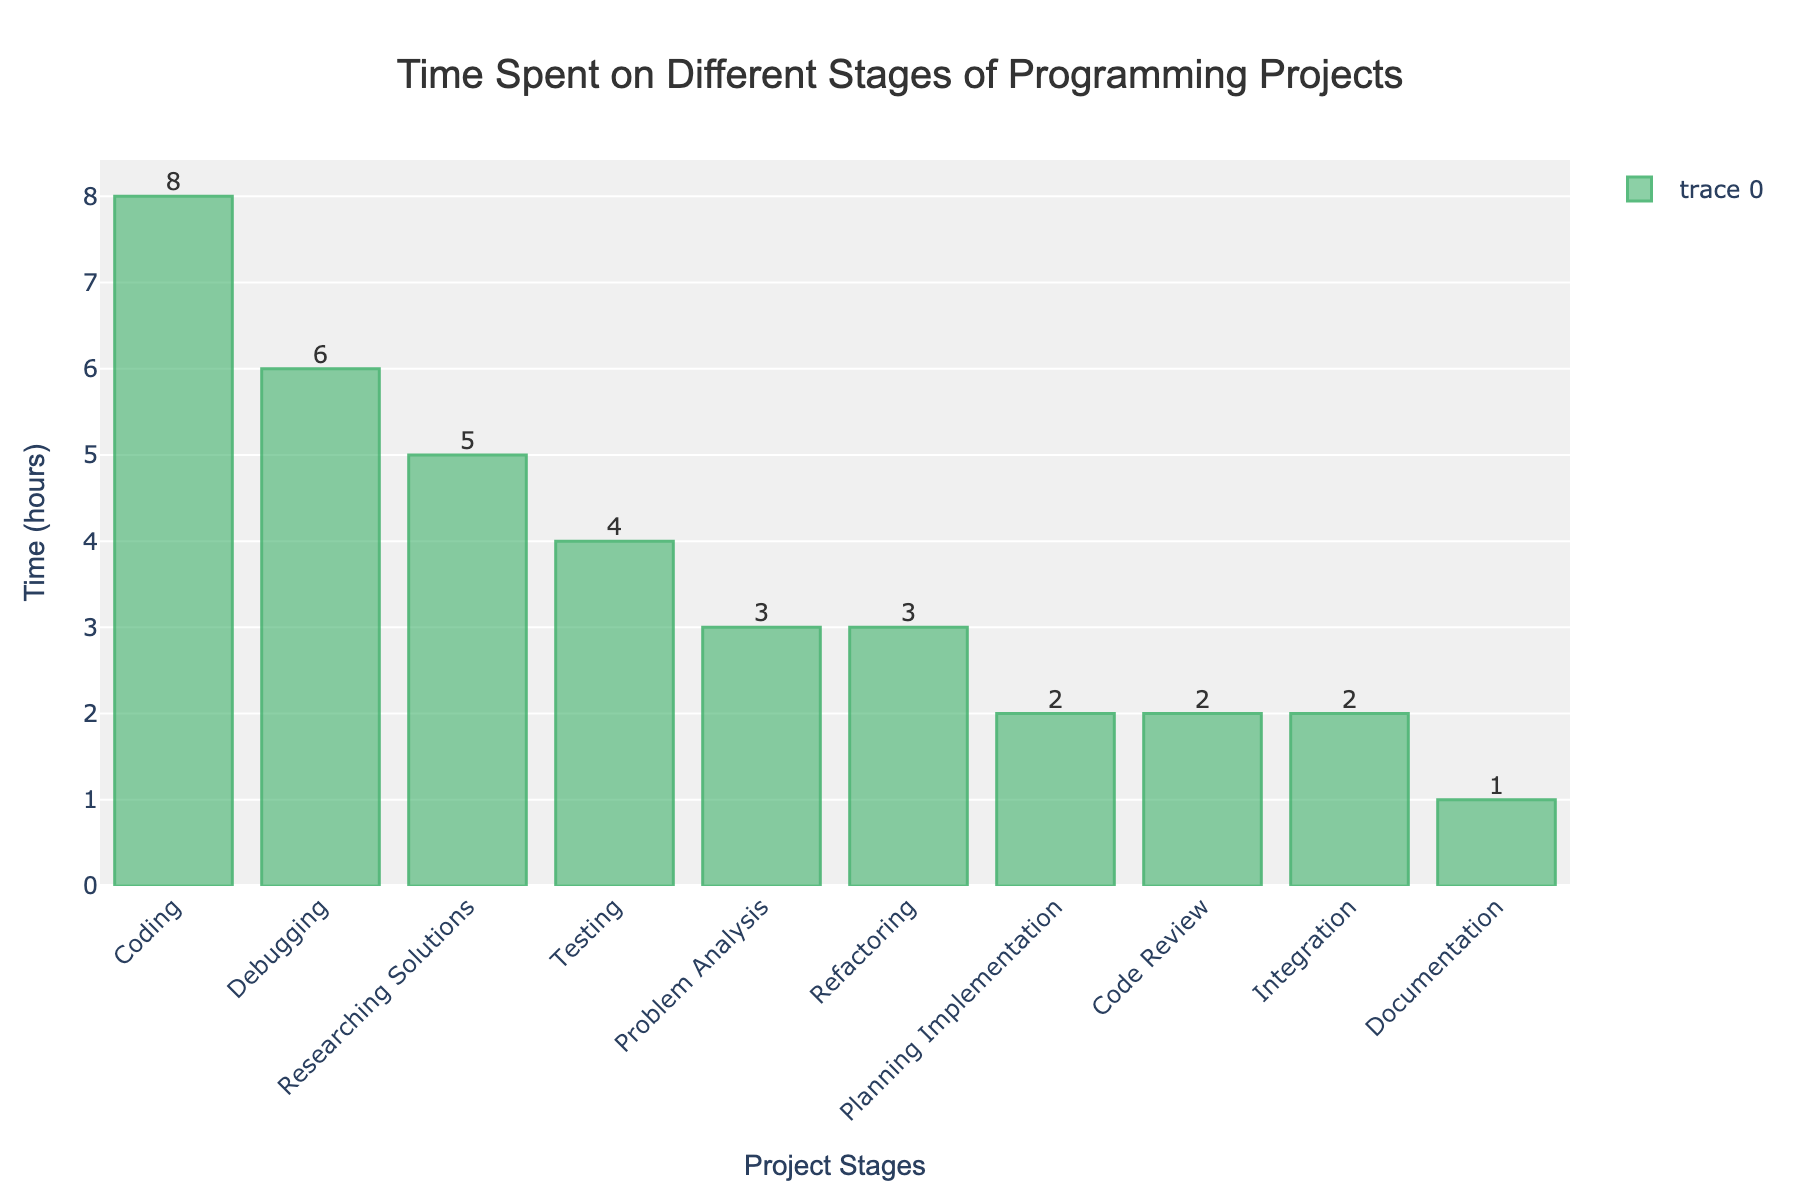What's the stage with the highest time spent? By looking at the height of the bars, we can see that the "Coding" stage has the tallest bar, indicating the highest time spent.
Answer: Coding Which stage has the smallest time spent? The "Documentation" stage has the shortest bar, indicating the smallest time spent.
Answer: Documentation How much total time is spent on "Debugging" and "Testing"? Add the time spent on "Debugging" and "Testing" (6 + 4).
Answer: 10 Which stages have equal time spent? By comparing the bar heights and the values on top of the bars, we see that "Planning Implementation", "Code Review", and "Integration" all have bars of equal height representing 2 hours.
Answer: Planning Implementation, Code Review, Integration What is the difference in time spent between "Researching Solutions" and "Planning Implementation"? Subtract the time spent on "Planning Implementation" from the time spent on "Researching Solutions" (5 - 2).
Answer: 3 What is the sum of the time spent on "Refactoring", "Documentation", and "Integration"? Add the time spent on "Refactoring", "Documentation", and "Integration" (3 + 1 + 2).
Answer: 6 Which two stages combined equal the time spent on "Debugging"? Comparing the values, we see that "Planning Implementation" and "Integration" combined (2 + 2) equal the time on "Debugging" (6). To confirm: 2 + 2 = 4, so "Refactoring" (3) and "Planning Implementation" (2) combined make 6.
Answer: Refactoring, Planning Implementation What is the average time spent on all stages? Sum all time spent on each stage: 3 + 5 + 2 + 8 + 6 + 4 + 1 + 2 + 3 + 2 = 36. There are 10 stages, so the average time spent = 36 / 10.
Answer: 3.6 Which stage contributes second highest to the total time spent? By looking at the bars, the tallest is "Coding" and the second tallest is "Debugging".
Answer: Debugging 